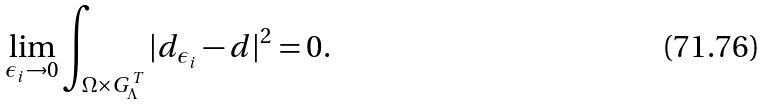Convert formula to latex. <formula><loc_0><loc_0><loc_500><loc_500>\lim _ { \epsilon _ { i } \rightarrow 0 } \int _ { \Omega \times G _ { \Lambda } ^ { T } } | d _ { \epsilon _ { i } } - d | ^ { 2 } = 0 .</formula> 